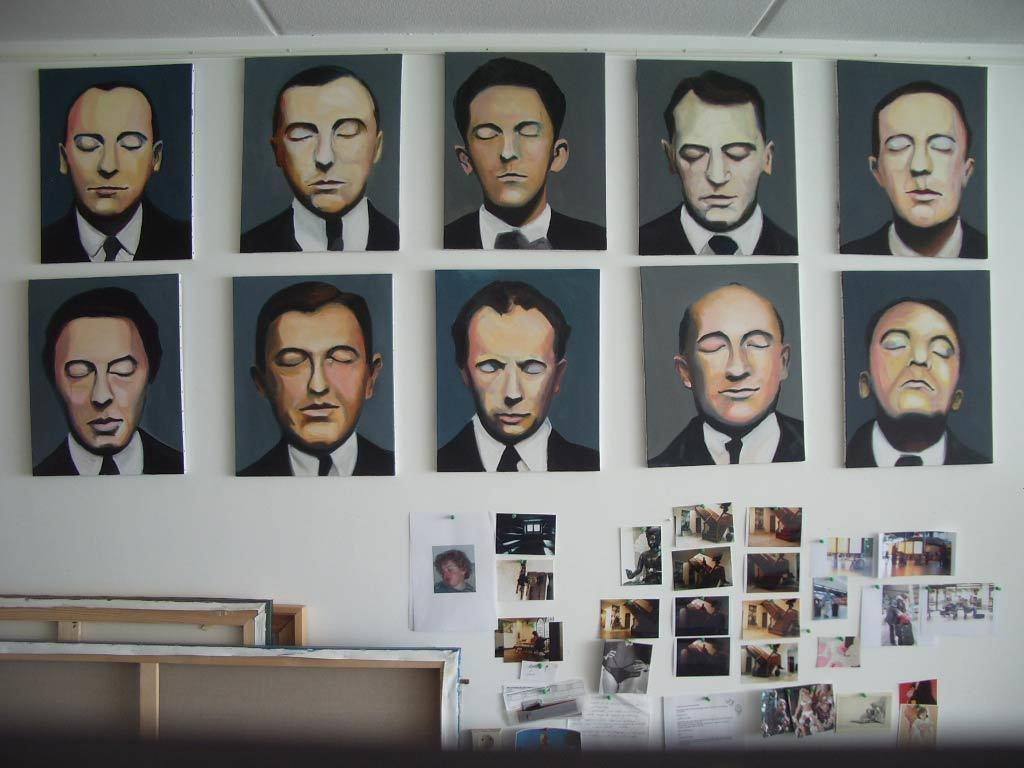What is on the wall in the image? There is a painting and images pasted on the wall in the image. What is the color of the wall? The wall is white in color. Where are the frames located in the image? The frames are at the left bottom of the image. How many geese are visible in the image? There are no geese present in the image. What type of owl can be seen perched on the painting in the image? There is no owl present in the image; it only features a painting and images pasted on the wall. 